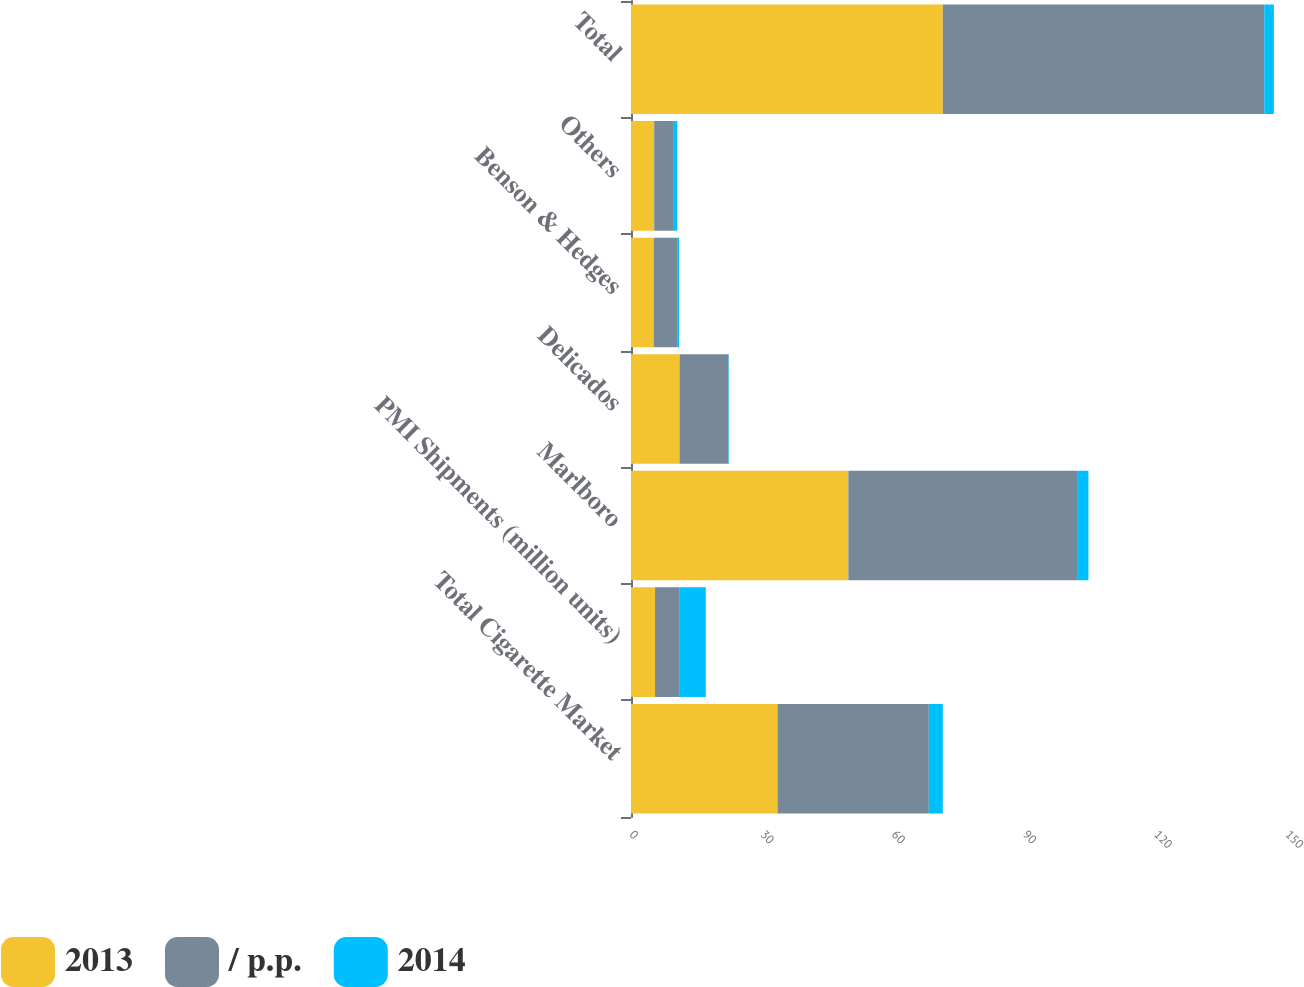Convert chart to OTSL. <chart><loc_0><loc_0><loc_500><loc_500><stacked_bar_chart><ecel><fcel>Total Cigarette Market<fcel>PMI Shipments (million units)<fcel>Marlboro<fcel>Delicados<fcel>Benson & Hedges<fcel>Others<fcel>Total<nl><fcel>2013<fcel>33.5<fcel>5.5<fcel>49.7<fcel>11.1<fcel>5.2<fcel>5.3<fcel>71.3<nl><fcel>/ p.p.<fcel>34.6<fcel>5.5<fcel>52.3<fcel>11.2<fcel>5.5<fcel>4.5<fcel>73.5<nl><fcel>2014<fcel>3.2<fcel>6.1<fcel>2.6<fcel>0.1<fcel>0.3<fcel>0.8<fcel>2.2<nl></chart> 